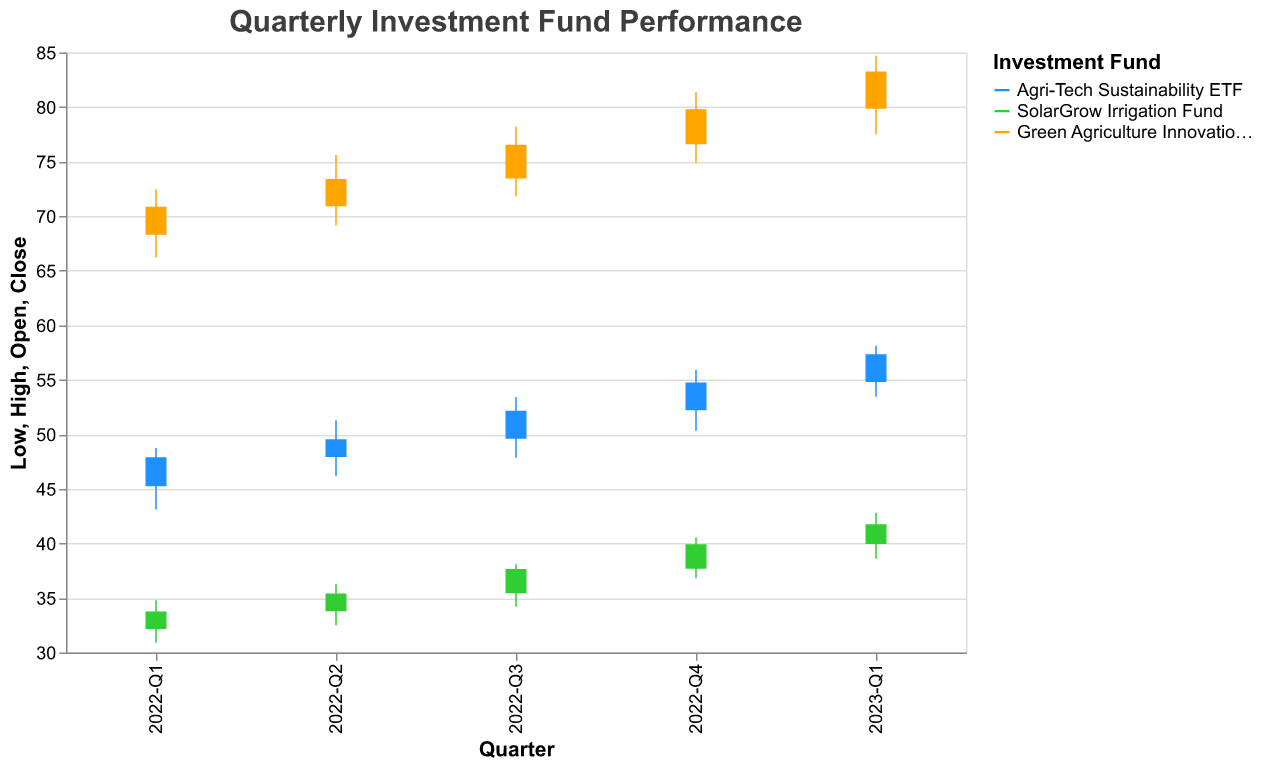What is the title of the figure? The title of the figure is usually found at the top of the graph, and it provides an overview of what the figure represents.
Answer: Quarterly Investment Fund Performance Which investment fund had the highest closing value in 2023-Q1? The highest closing value in 2023-Q1 can be found by identifying the bar that extends the highest on the y-axis for that period.
Answer: Green Agriculture Innovation Index What is the color used to represent the SolarGrow Irrigation Fund? The colors representing each fund can be identified from the legend on the chart. The SolarGrow Irrigation Fund has a distinct color compared to the other funds.
Answer: Green How did the Agri-Tech Sustainability ETF perform between 2022-Q1 and 2022-Q2 in terms of closing value? Compare the closing values from 2022-Q1 and 2022-Q2 for the Agri-Tech Sustainability ETF. The closing value for 2022-Q1 is 47.89, and for 2022-Q2 it is 49.55.
Answer: Improved What was the high value for the Green Agriculture Innovation Index in 2022-Q3? Look at the peak of the vertical line segment representing the Green Agriculture Innovation Index for 2022-Q3.
Answer: 78.20 How much did the SolarGrow Irrigation Fund’s closing value increase from 2022-Q4 to 2023-Q1? Calculate the difference between the closing values of the SolarGrow Irrigation Fund for 2022-Q4 (39.92) and 2023-Q1 (41.75). 41.75 - 39.92 = 1.83
Answer: 1.83 Which investment fund had the least volatility in 2022-Q1? Volatility can be identified by the height of the vertical lines (difference between the high and low values) for each fund in 2022-Q1. The smaller the height, the less volatility.
Answer: SolarGrow Irrigation Fund What is the average opening value for the Agri-Tech Sustainability ETF across all given quarters? Sum the opening values for the Agri-Tech Sustainability ETF and divide by the number of quarters reported: (45.23 + 47.92 + 49.60 + 52.20 + 54.80) / 5 = 49.15
Answer: 49.15 Which fund had the highest increase in closing value from 2022-Q1 to 2023-Q1? To find the highest increase, calculate the difference between the closing values for each fund between 2022-Q1 and 2023-Q1, and compare the results: Agri-Tech (57.33 - 47.89 = 9.44), SolarGrow (41.75 - 33.75 = 8.00), Green Agri (83.25 - 70.85 = 12.40). The highest difference is for the Green Agriculture Innovation Index.
Answer: Green Agriculture Innovation Index 